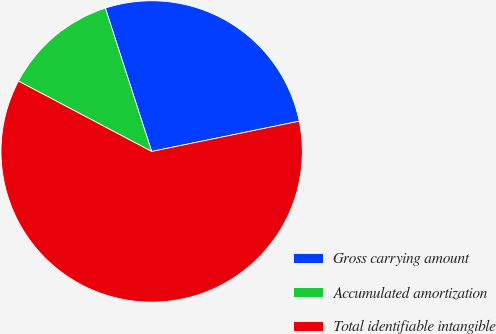<chart> <loc_0><loc_0><loc_500><loc_500><pie_chart><fcel>Gross carrying amount<fcel>Accumulated amortization<fcel>Total identifiable intangible<nl><fcel>26.75%<fcel>12.29%<fcel>60.96%<nl></chart> 